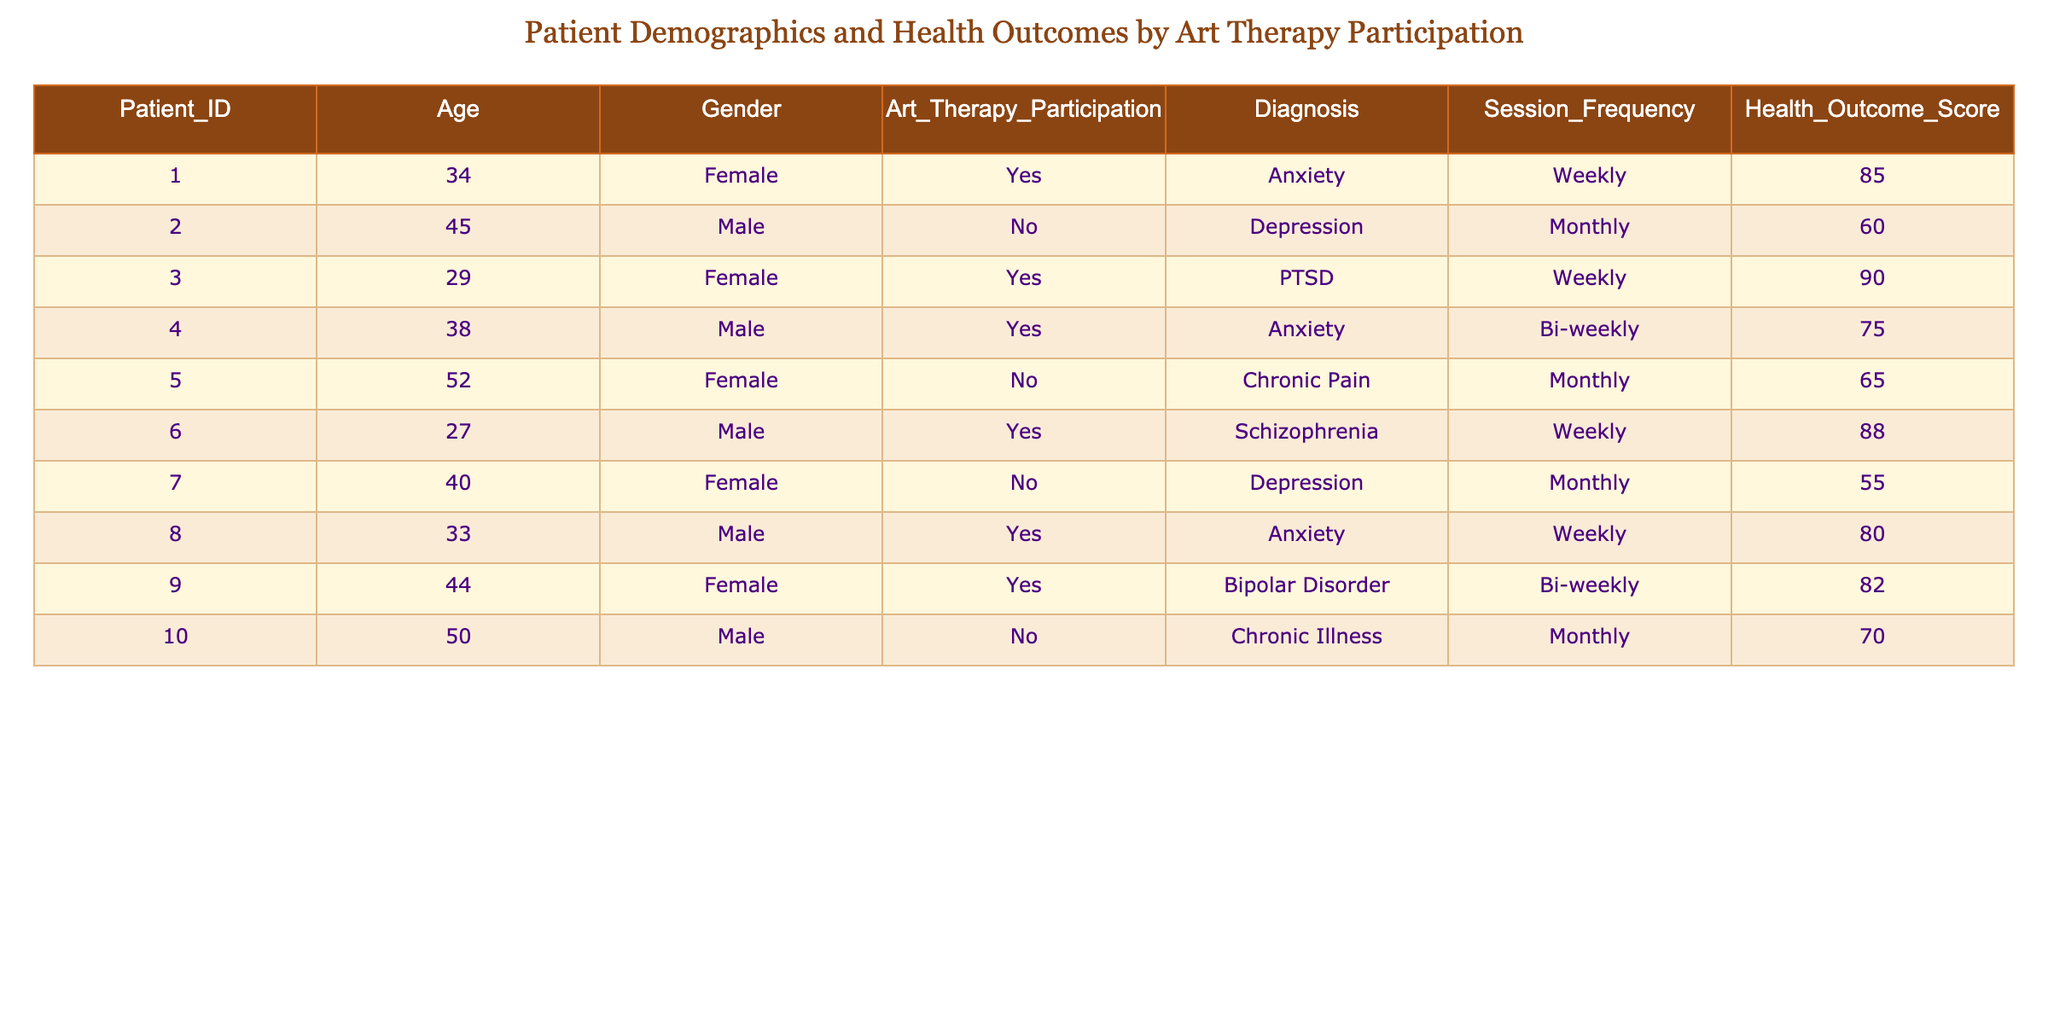What is the Health Outcome Score for the patient diagnosed with chronic pain who did not participate in art therapy? The table shows that the patient with Chronic Pain who did not participate in art therapy is Patient_ID 5, and their Health Outcome Score is 65.
Answer: 65 How many patients participated in art therapy? To find the number of patients who participated in art therapy, we can count the entries where the Art Therapy Participation column has "Yes." From the table, there are 5 patients who participated in art therapy.
Answer: 5 What is the average Health Outcome Score for patients who participated in art therapy? To find the average for patients who participated in art therapy, we first list their Health Outcome Scores: 85, 90, 75, 88, 80, and 82. The sum is 85 + 90 + 75 + 88 + 80 + 82 = 510. There are 6 patients, so the average is 510 / 6 = 85.
Answer: 85 Are there more female patients than male patients in the art therapy group? In the art therapy group, we have the following genders: Female (3) and Male (2). Since 3 is greater than 2, there are indeed more female patients in the art therapy group.
Answer: Yes What is the Health Outcome Score of the oldest patient in the table? First, we need to identify the oldest patient by looking at the Age column. Patient_ID 5 is the oldest with an age of 52, and their Health Outcome Score is 65.
Answer: 65 What is the difference in Health Outcome Scores between patients with anxiety participating in art therapy and those with depression not participating? The Health Outcome Score for the patient with anxiety in art therapy (Patient_ID 1) is 85, and for the patient with depression who did not participate (Patient_ID 2) it is 60. The difference is 85 - 60 = 25.
Answer: 25 Is there a patient with a Health Outcome Score below 60 who participated in art therapy? Checking the Health Outcome Scores of patients who participated in art therapy, we see scores of 85, 90, 75, 88, 80, and 82. All these scores are above 60, meaning there is no such patient.
Answer: No What is the Health Outcome Score of the youngest male patient who participated in art therapy? First, identify the male patients in the art therapy group: Patient_ID 6 (27 years, Score 88) and Patient_ID 4 (38 years, Score 75). The youngest is Patient_ID 6 with a Score of 88.
Answer: 88 